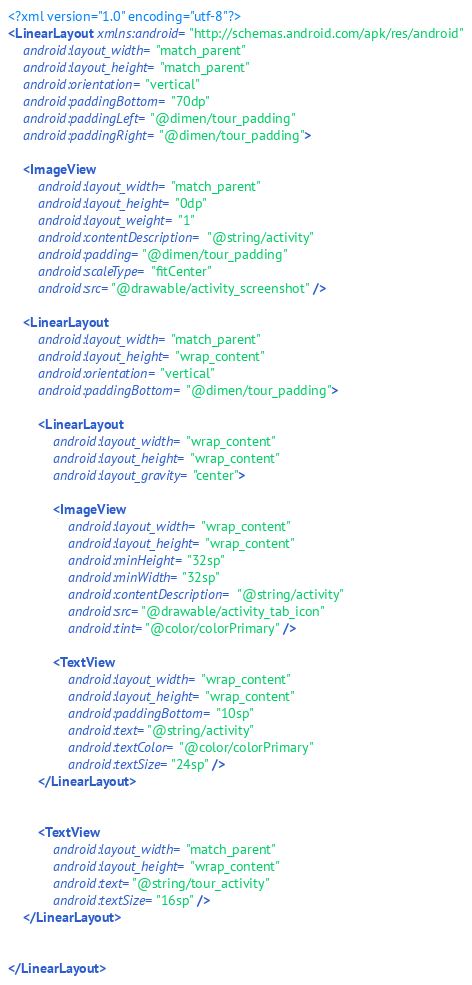Convert code to text. <code><loc_0><loc_0><loc_500><loc_500><_XML_><?xml version="1.0" encoding="utf-8"?>
<LinearLayout xmlns:android="http://schemas.android.com/apk/res/android"
    android:layout_width="match_parent"
    android:layout_height="match_parent"
    android:orientation="vertical"
    android:paddingBottom="70dp"
    android:paddingLeft="@dimen/tour_padding"
    android:paddingRight="@dimen/tour_padding">

    <ImageView
        android:layout_width="match_parent"
        android:layout_height="0dp"
        android:layout_weight="1"
        android:contentDescription="@string/activity"
        android:padding="@dimen/tour_padding"
        android:scaleType="fitCenter"
        android:src="@drawable/activity_screenshot" />

    <LinearLayout
        android:layout_width="match_parent"
        android:layout_height="wrap_content"
        android:orientation="vertical"
        android:paddingBottom="@dimen/tour_padding">

        <LinearLayout
            android:layout_width="wrap_content"
            android:layout_height="wrap_content"
            android:layout_gravity="center">

            <ImageView
                android:layout_width="wrap_content"
                android:layout_height="wrap_content"
                android:minHeight="32sp"
                android:minWidth="32sp"
                android:contentDescription="@string/activity"
                android:src="@drawable/activity_tab_icon"
                android:tint="@color/colorPrimary" />

            <TextView
                android:layout_width="wrap_content"
                android:layout_height="wrap_content"
                android:paddingBottom="10sp"
                android:text="@string/activity"
                android:textColor="@color/colorPrimary"
                android:textSize="24sp" />
        </LinearLayout>


        <TextView
            android:layout_width="match_parent"
            android:layout_height="wrap_content"
            android:text="@string/tour_activity"
            android:textSize="16sp" />
    </LinearLayout>


</LinearLayout></code> 